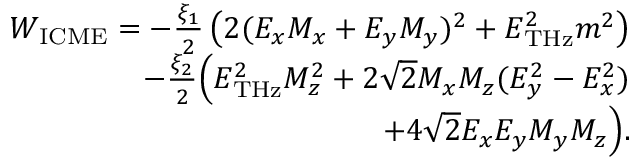Convert formula to latex. <formula><loc_0><loc_0><loc_500><loc_500>\begin{array} { r } { W _ { I C M E } = - \frac { \xi _ { 1 } } { 2 } \left ( 2 ( E _ { x } M _ { x } + E _ { y } M _ { y } ) ^ { 2 } + E _ { T H z } ^ { 2 } m ^ { 2 } \right ) } \\ { - \frac { \xi _ { 2 } } { 2 } \left ( E _ { T H z } ^ { 2 } M _ { z } ^ { 2 } + 2 \sqrt { 2 } M _ { x } M _ { z } ( E _ { y } ^ { 2 } - E _ { x } ^ { 2 } ) } \\ { + 4 \sqrt { 2 } E _ { x } E _ { y } M _ { y } M _ { z } \right ) . } \end{array}</formula> 